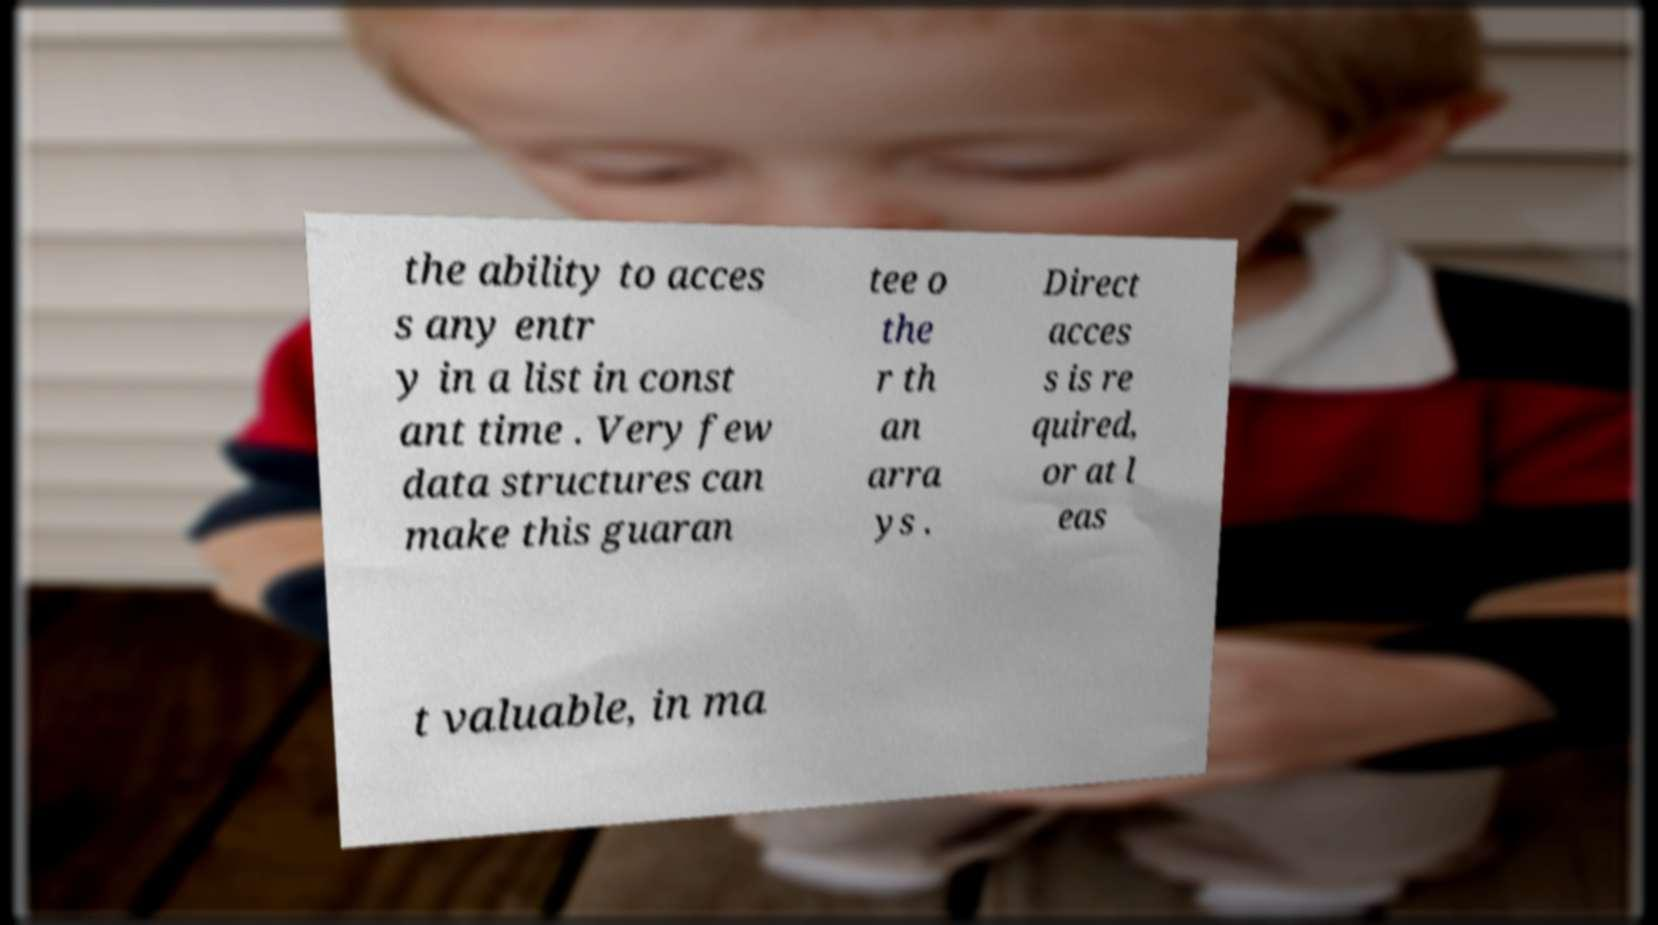Could you assist in decoding the text presented in this image and type it out clearly? the ability to acces s any entr y in a list in const ant time . Very few data structures can make this guaran tee o the r th an arra ys . Direct acces s is re quired, or at l eas t valuable, in ma 